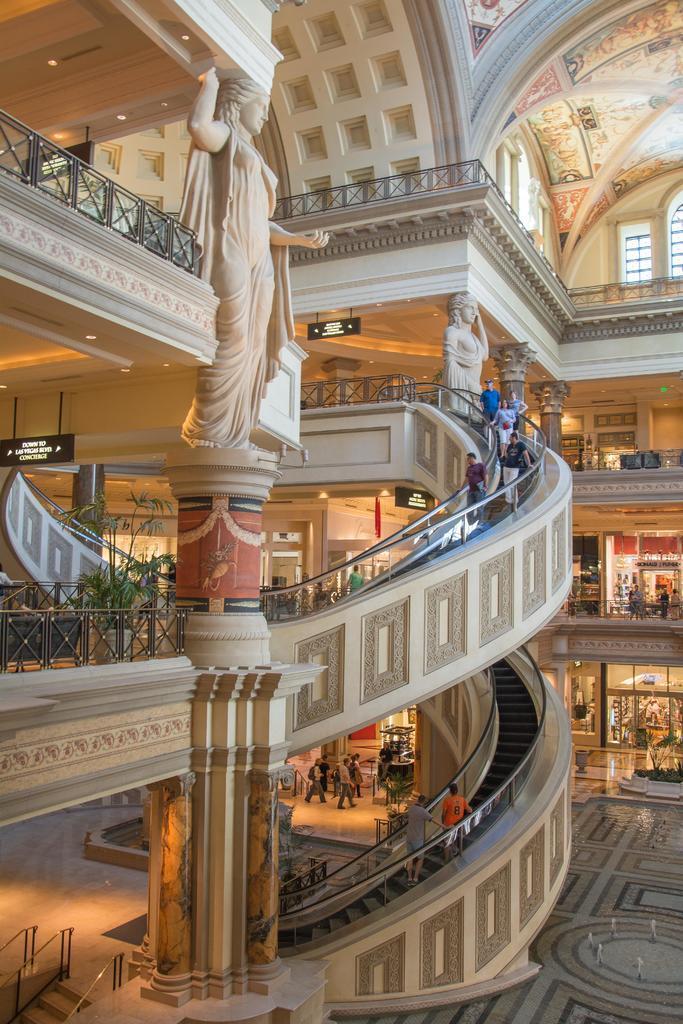In one or two sentences, can you explain what this image depicts? In this picture we can see the inside view of a building. Here we can see escalators, pillars, statues, boards, railings, ceilings, lights, windows, and people. 